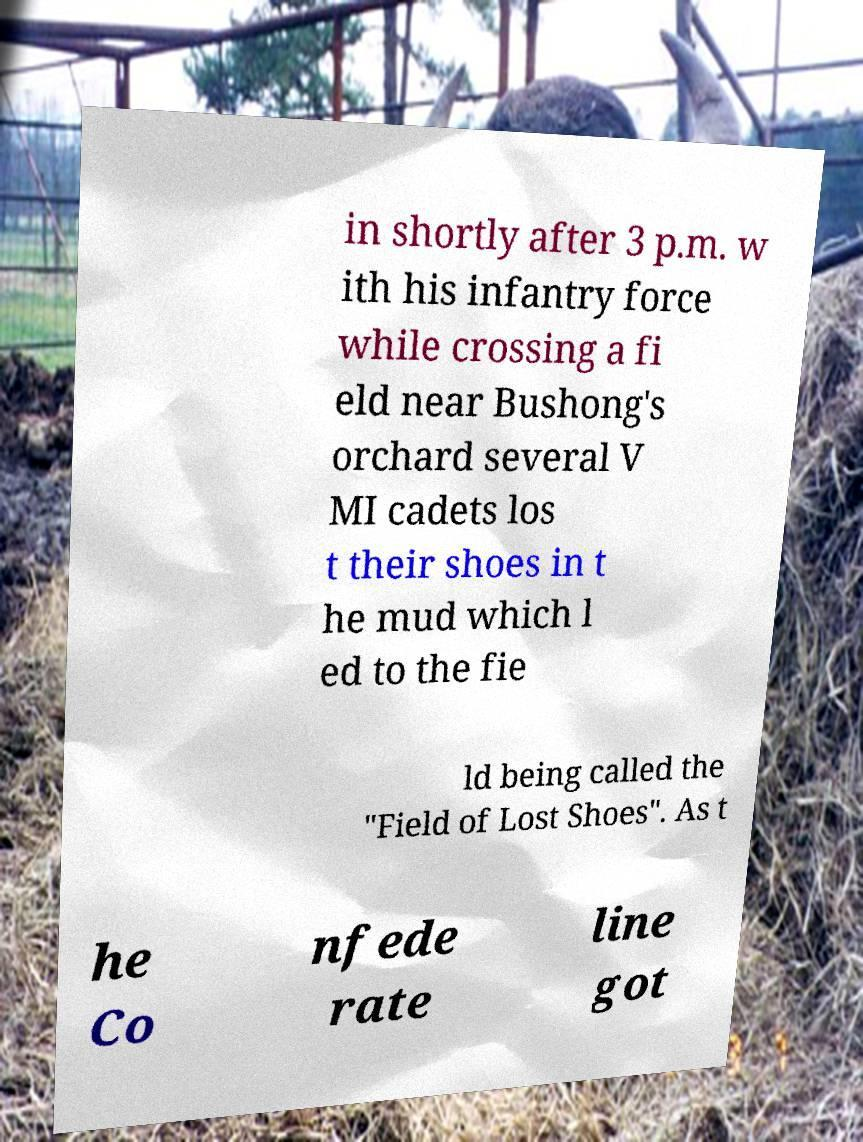Please identify and transcribe the text found in this image. in shortly after 3 p.m. w ith his infantry force while crossing a fi eld near Bushong's orchard several V MI cadets los t their shoes in t he mud which l ed to the fie ld being called the "Field of Lost Shoes". As t he Co nfede rate line got 